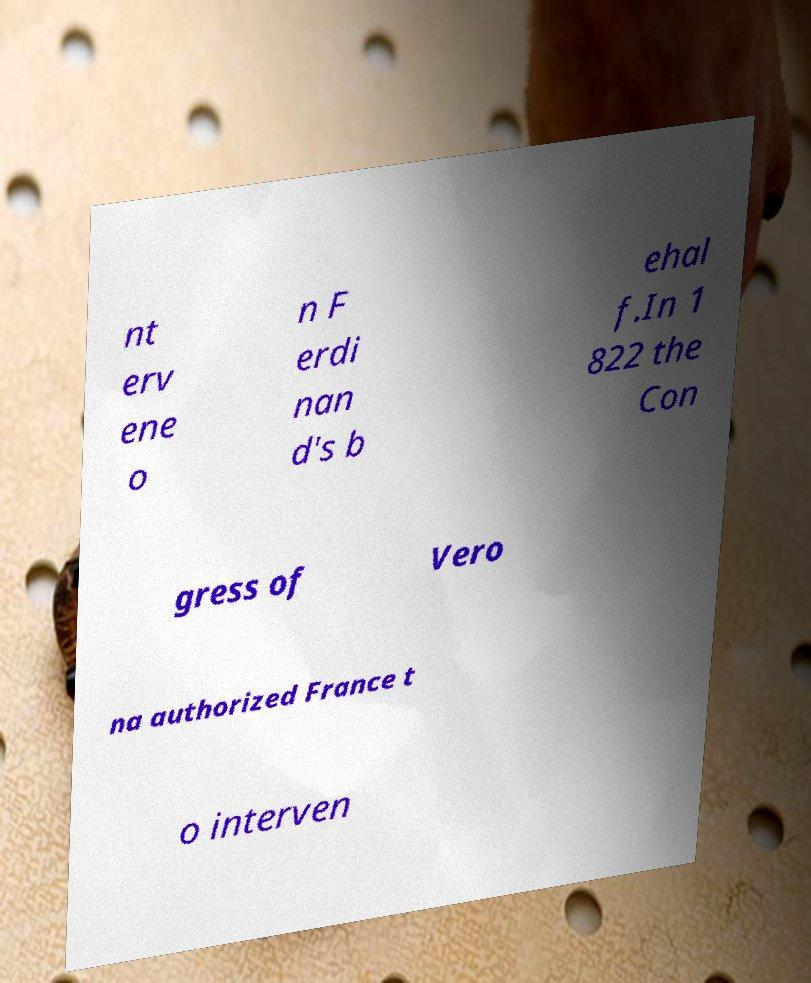I need the written content from this picture converted into text. Can you do that? nt erv ene o n F erdi nan d's b ehal f.In 1 822 the Con gress of Vero na authorized France t o interven 